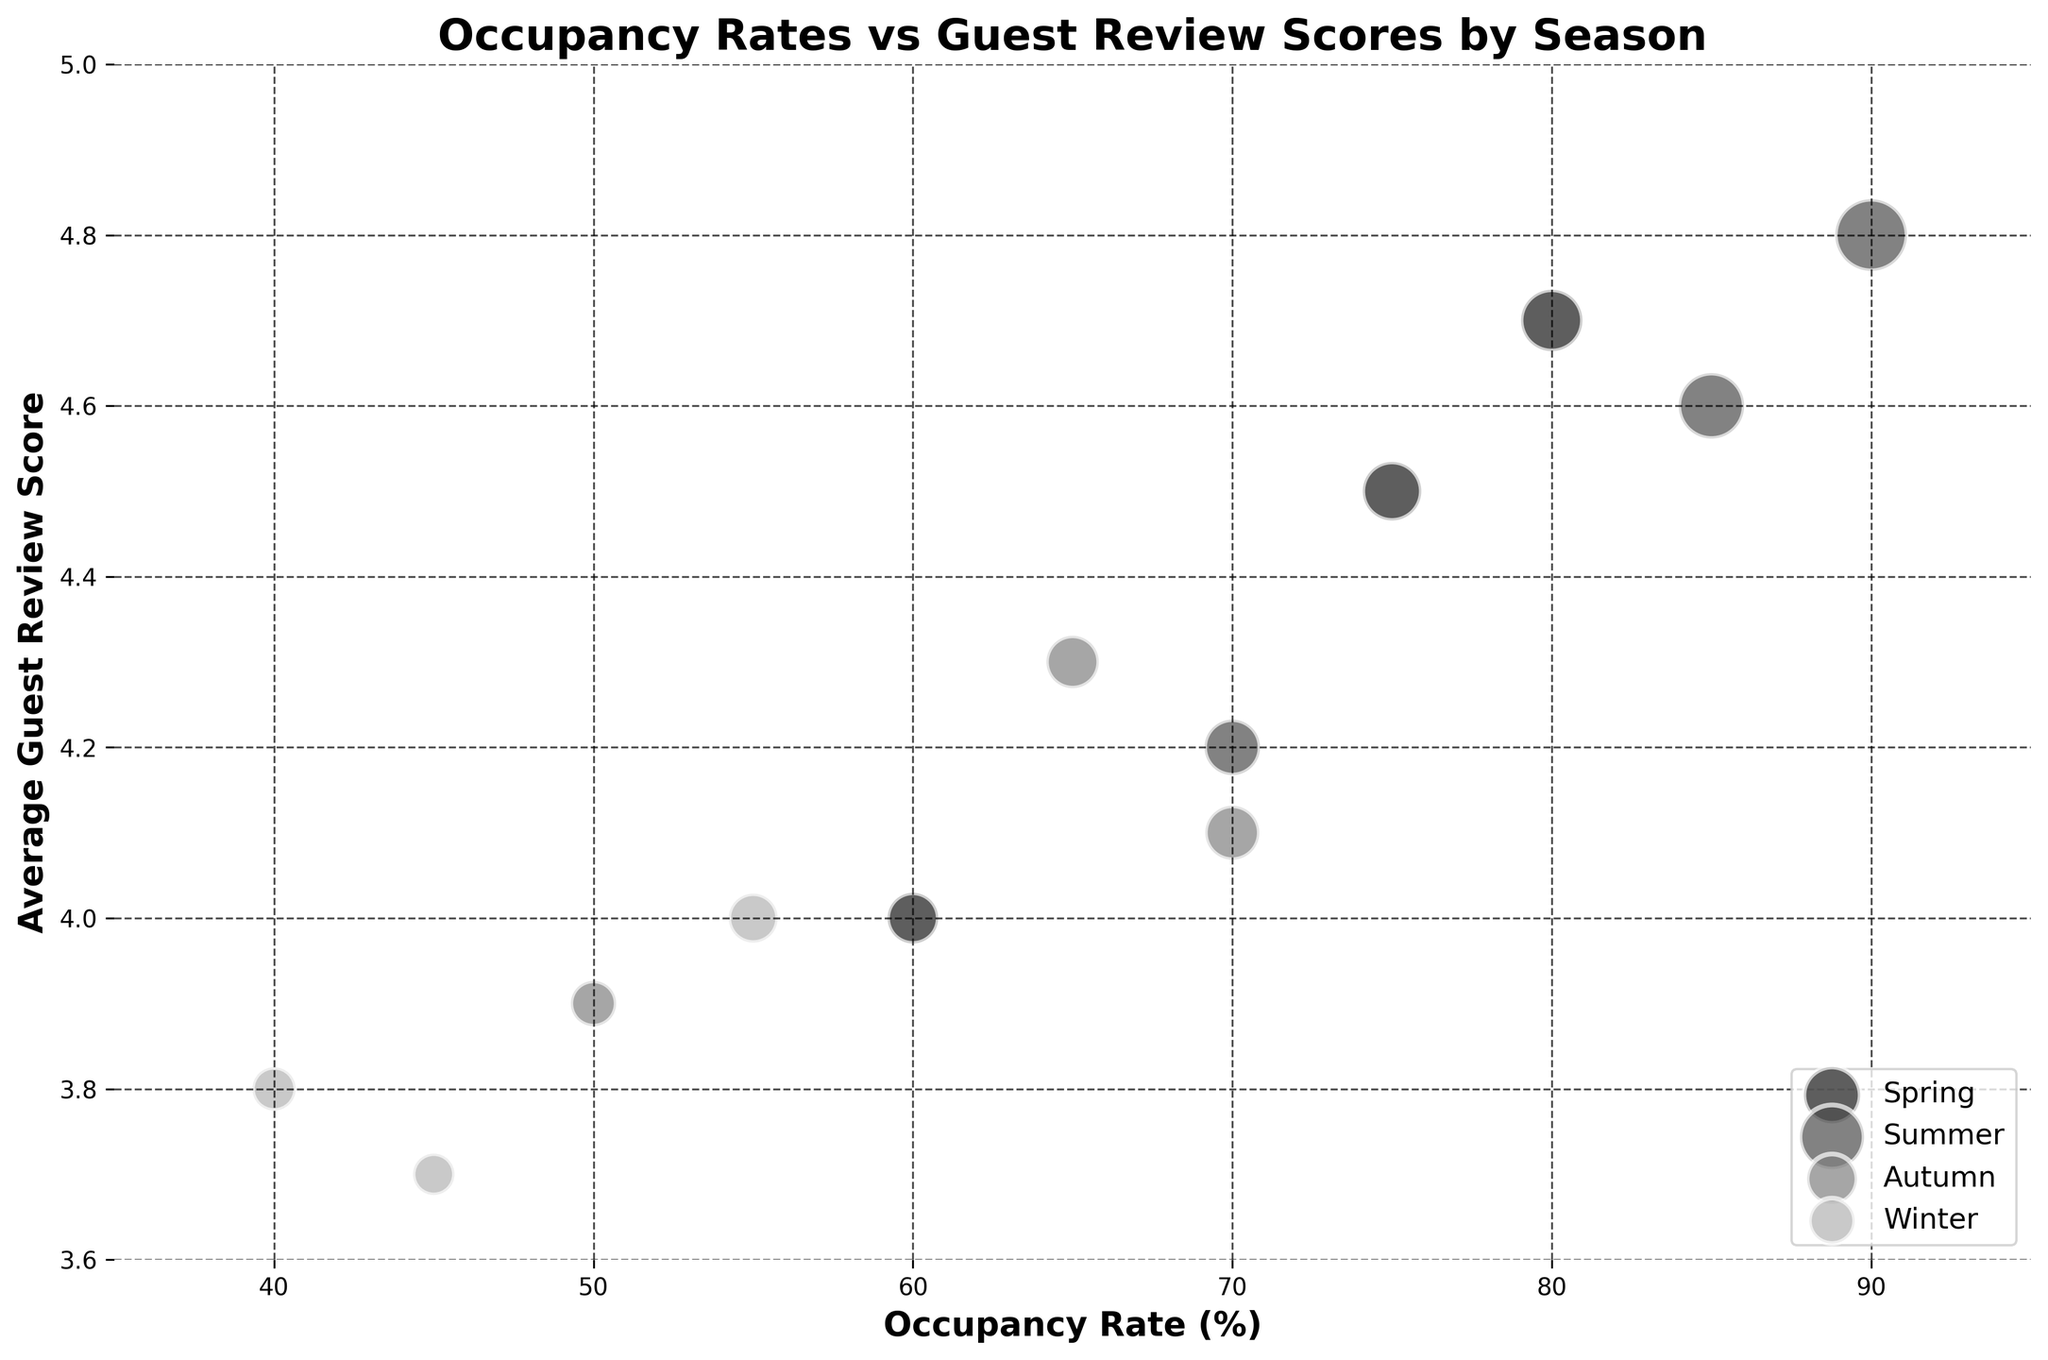What is the title of the chart? The title is usually found at the top of the chart and summarizes the main idea being presented. In this case, it would read "Occupancy Rates vs Guest Review Scores by Season".
Answer: Occupancy Rates vs Guest Review Scores by Season What are the x-axis and y-axis labels? The x-axis and y-axis labels are usually found right beside each axis. Here, the x-axis is labeled "Occupancy Rate (%)" and the y-axis is labeled "Average Guest Review Score".
Answer: Occupancy Rate (%) and Average Guest Review Score Which season has the highest occupancy rate? Visual observation shows that the highest occupancy rate falls within the "Summer" season, with marked rates reaching up to 90%.
Answer: Summer How many data points are displayed for each season? By counting the bubbles in the figure, we can see 3 data points each for Spring, Summer, Autumn, and Winter.
Answer: 3 Compare the average guest review score for the highest occupancy rate in Summer and Winter. The highest occupancy rate in Summer is 90% with a guest review score of 4.8. In Winter, the highest occupancy rate is 55% with a guest review score of 4.0.
Answer: 4.8 in Summer and 4.0 in Winter Which data point has the largest bubble size? Looking for the largest bubble visually, we can see the largest bubble size is in the Summer season with an occupancy rate of 90% and a review score of 4.8. This would correspond to a bubble size of 300.
Answer: Summer with an occupancy rate of 90% and review score of 4.8 What is the average occupancy rate for Spring? Add the three occupancy rates for Spring (75%, 60%, 80%) and divide by the number of data points: (75+60+80)/3 = 71.67%.
Answer: 71.67% Excluding Winter, which season has the lowest average guest review score? Calculate the average guest review scores for each season excluding Winter: Spring = (4.5 + 4.0 + 4.7)/3 = 4.4, Summer = (4.8 + 4.6 + 4.2)/3 = 4.53, Autumn = (4.3 + 4.1 + 3.9)/3 = 4.1. Hence, Autumn has the lowest average score.
Answer: Autumn In which season are bubbles more concentrated towards the higher occupancy rate? By observing the scatter data arrangement, it is clear that in Summer, more bubbles are concentrated towards the higher occupancy rates of 70%-90%.
Answer: Summer How does the average guest review score change from Winter to Summer for the highest occupancy data points? The highest occupancy data points have a score of 4.8 in Summer (90%) and a score of 4.0 in Winter (55%). Therefore, from Winter to Summer, the score increases by 0.8.
Answer: Increases by 0.8 